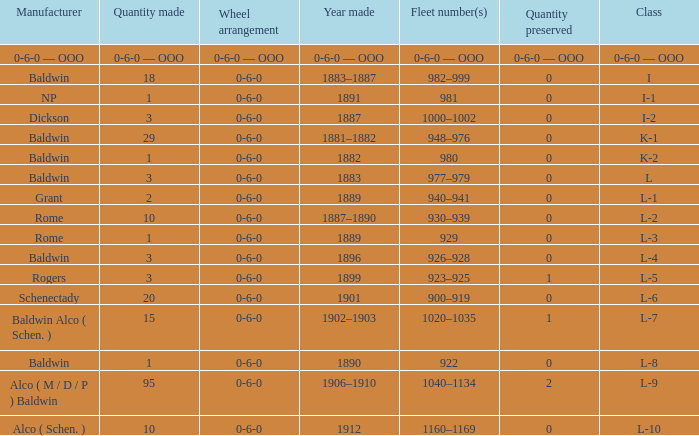Which Class has a Quantity made of 29? K-1. 